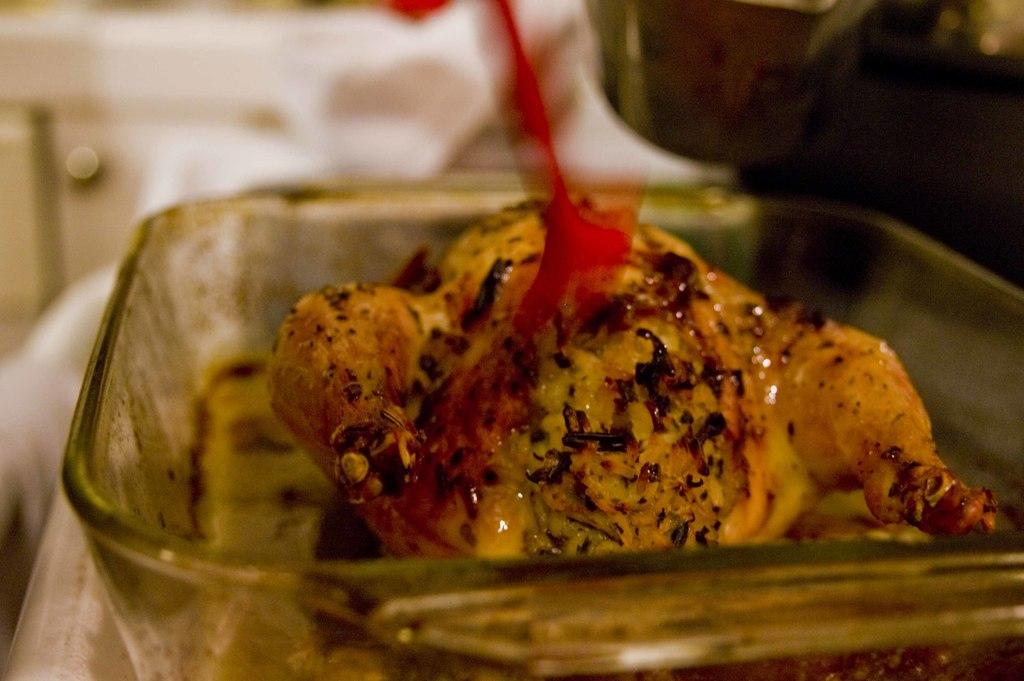What is the main subject of the image? There is a food item in the image. How is the food item contained or displayed? The food item is in a glass tray. Can you describe the background of the image? The background of the image is blurred. How many actors are visible in the image? There are no actors present in the image; it features a food item in a glass tray with a blurred background. What type of plate is the food item served on in the image? The provided facts do not mention a plate; the food item is in a glass tray. 